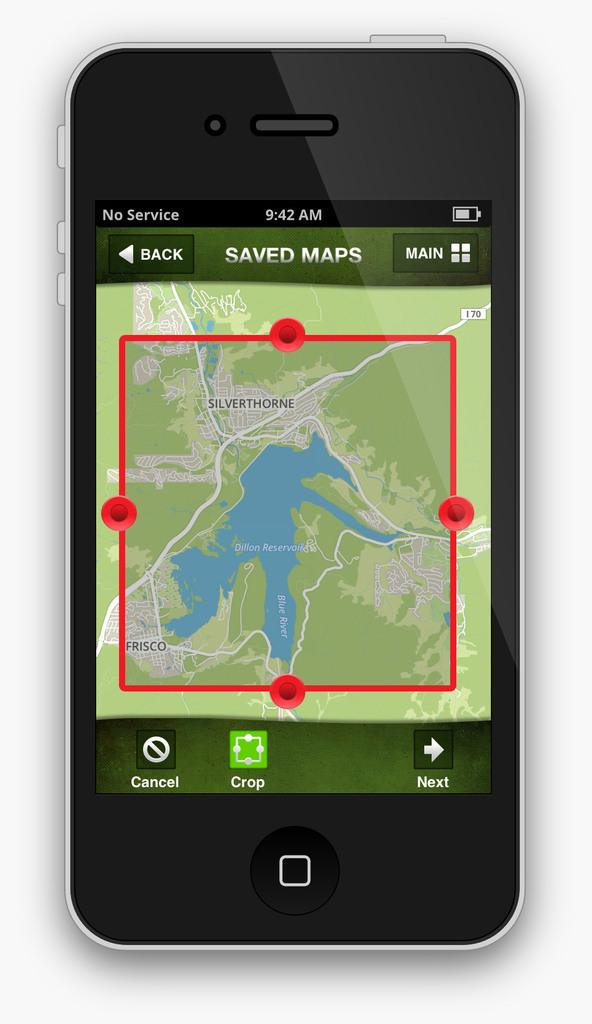Provide a one-sentence caption for the provided image. A map app on a smartphone that is on the Saved Maps screen. 